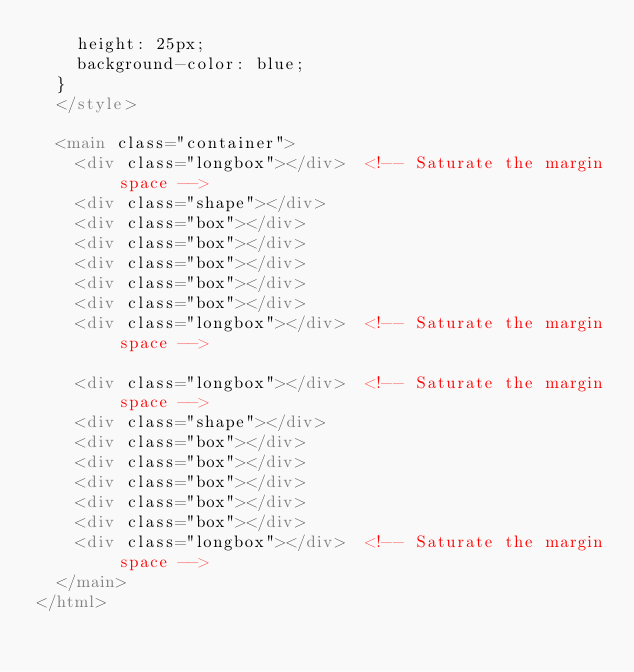Convert code to text. <code><loc_0><loc_0><loc_500><loc_500><_HTML_>    height: 25px;
    background-color: blue;
  }
  </style>

  <main class="container">
    <div class="longbox"></div>  <!-- Saturate the margin space -->
    <div class="shape"></div>
    <div class="box"></div>
    <div class="box"></div>
    <div class="box"></div>
    <div class="box"></div>
    <div class="box"></div>
    <div class="longbox"></div>  <!-- Saturate the margin space -->

    <div class="longbox"></div>  <!-- Saturate the margin space -->
    <div class="shape"></div>
    <div class="box"></div>
    <div class="box"></div>
    <div class="box"></div>
    <div class="box"></div>
    <div class="box"></div>
    <div class="longbox"></div>  <!-- Saturate the margin space -->
  </main>
</html>
</code> 